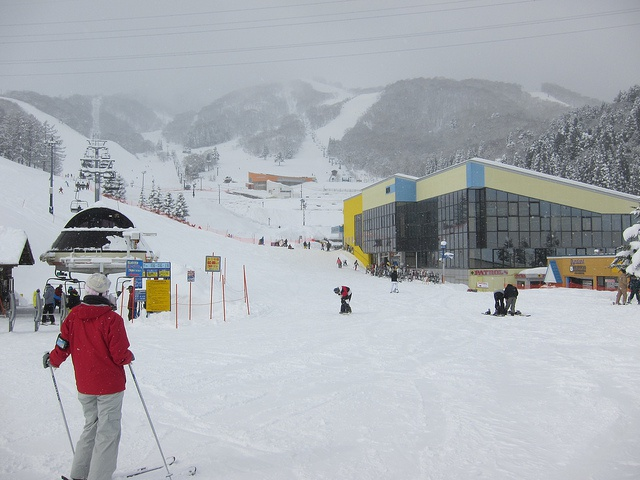Describe the objects in this image and their specific colors. I can see people in darkgray, brown, maroon, and gray tones, people in darkgray, lightgray, gray, and black tones, skis in darkgray and lightgray tones, people in darkgray, black, gray, and lightgray tones, and people in darkgray, gray, black, and darkblue tones in this image. 